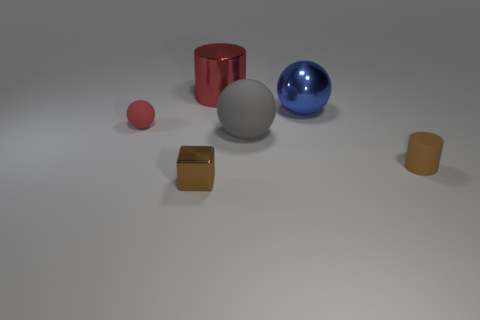How many balls are both to the right of the big cylinder and in front of the blue object?
Your response must be concise. 1. There is a shiny object in front of the blue metal thing; does it have the same size as the red thing to the right of the brown block?
Keep it short and to the point. No. There is a brown object that is in front of the tiny cylinder; what size is it?
Offer a very short reply. Small. What number of objects are small brown objects that are on the right side of the red shiny thing or objects that are in front of the brown rubber cylinder?
Your answer should be very brief. 2. Is there any other thing of the same color as the rubber cylinder?
Keep it short and to the point. Yes. Are there an equal number of red matte spheres on the right side of the tiny red matte sphere and brown cylinders to the left of the shiny sphere?
Give a very brief answer. Yes. Is the number of tiny brown rubber cylinders in front of the tiny brown metallic cube greater than the number of gray objects?
Make the answer very short. No. How many objects are either big balls in front of the large metal ball or big blue matte blocks?
Your response must be concise. 1. How many small spheres are made of the same material as the big gray thing?
Provide a succinct answer. 1. What shape is the metallic object that is the same color as the tiny cylinder?
Your answer should be compact. Cube. 